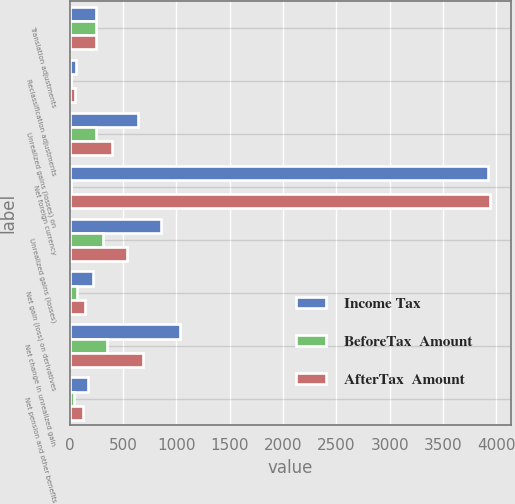Convert chart to OTSL. <chart><loc_0><loc_0><loc_500><loc_500><stacked_bar_chart><ecel><fcel>Translation adjustments<fcel>Reclassification adjustments<fcel>Unrealized gains (losses) on<fcel>Net foreign currency<fcel>Unrealized gains (losses)<fcel>Net gain (loss) on derivatives<fcel>Net change in unrealized gain<fcel>Net pension and other benefits<nl><fcel>Income Tax<fcel>243.5<fcel>63<fcel>637<fcel>3926<fcel>853<fcel>215<fcel>1034<fcel>169<nl><fcel>BeforeTax  Amount<fcel>243<fcel>14<fcel>244<fcel>15<fcel>314<fcel>73<fcel>350<fcel>43<nl><fcel>AfterTax  Amount<fcel>243.5<fcel>49<fcel>393<fcel>3941<fcel>539<fcel>142<fcel>684<fcel>126<nl></chart> 